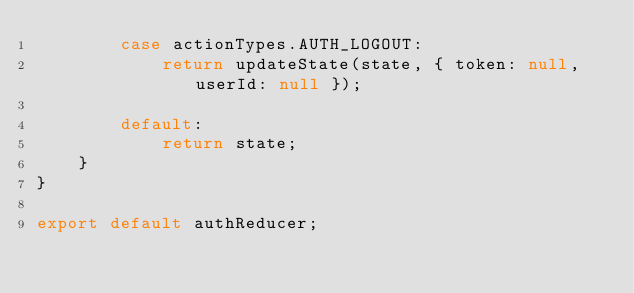Convert code to text. <code><loc_0><loc_0><loc_500><loc_500><_JavaScript_>        case actionTypes.AUTH_LOGOUT:
            return updateState(state, { token: null, userId: null });

        default:
            return state;
    }
}

export default authReducer;</code> 